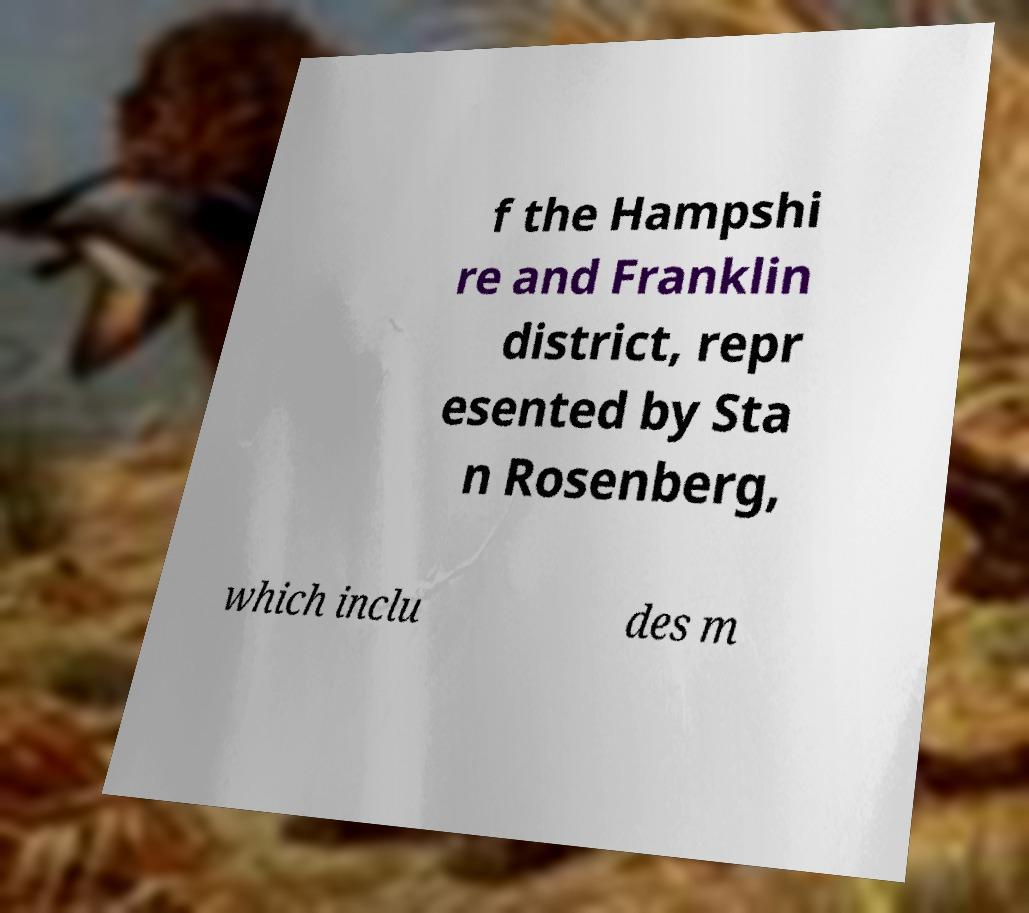Can you read and provide the text displayed in the image?This photo seems to have some interesting text. Can you extract and type it out for me? f the Hampshi re and Franklin district, repr esented by Sta n Rosenberg, which inclu des m 